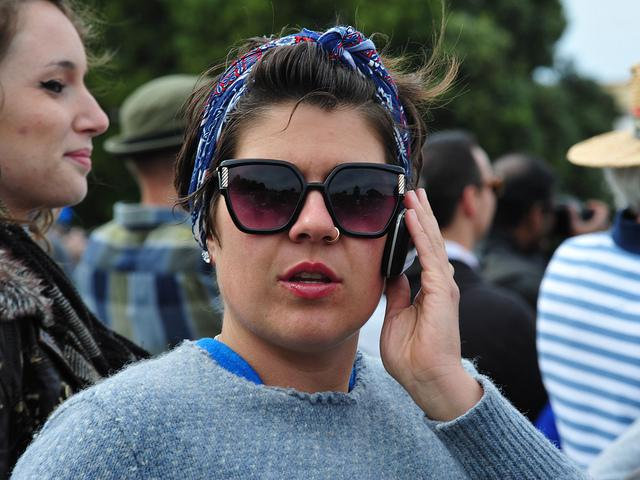What is the most likely purpose for the glasses on the girls face? Please explain your reasoning. blocking sun. It's a sunny day so it's safe to assume that she's wearing glasses for sun-blocking purposes. 